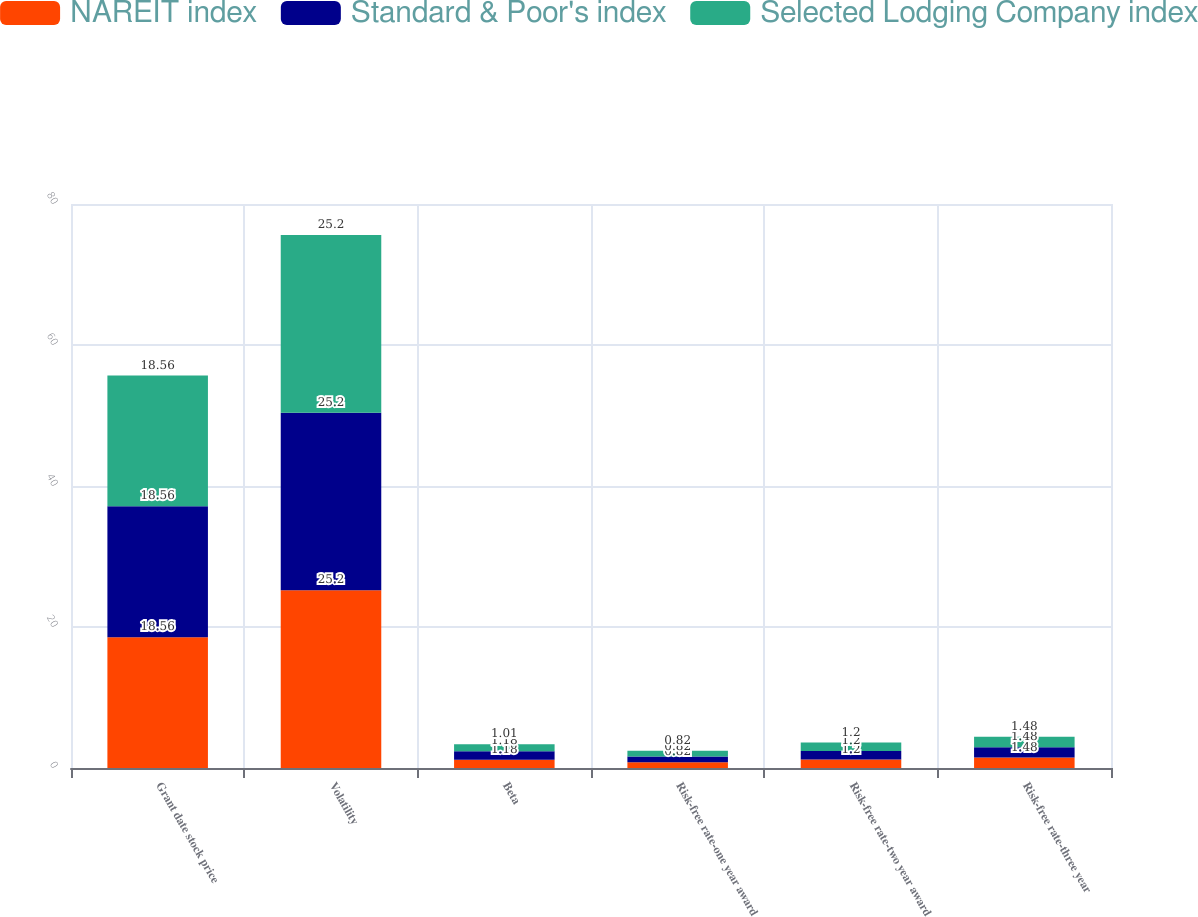Convert chart. <chart><loc_0><loc_0><loc_500><loc_500><stacked_bar_chart><ecel><fcel>Grant date stock price<fcel>Volatility<fcel>Beta<fcel>Risk-free rate-one year award<fcel>Risk-free rate-two year award<fcel>Risk-free rate-three year<nl><fcel>NAREIT index<fcel>18.56<fcel>25.2<fcel>1.18<fcel>0.82<fcel>1.2<fcel>1.48<nl><fcel>Standard & Poor's index<fcel>18.56<fcel>25.2<fcel>1.18<fcel>0.82<fcel>1.2<fcel>1.48<nl><fcel>Selected Lodging Company index<fcel>18.56<fcel>25.2<fcel>1.01<fcel>0.82<fcel>1.2<fcel>1.48<nl></chart> 